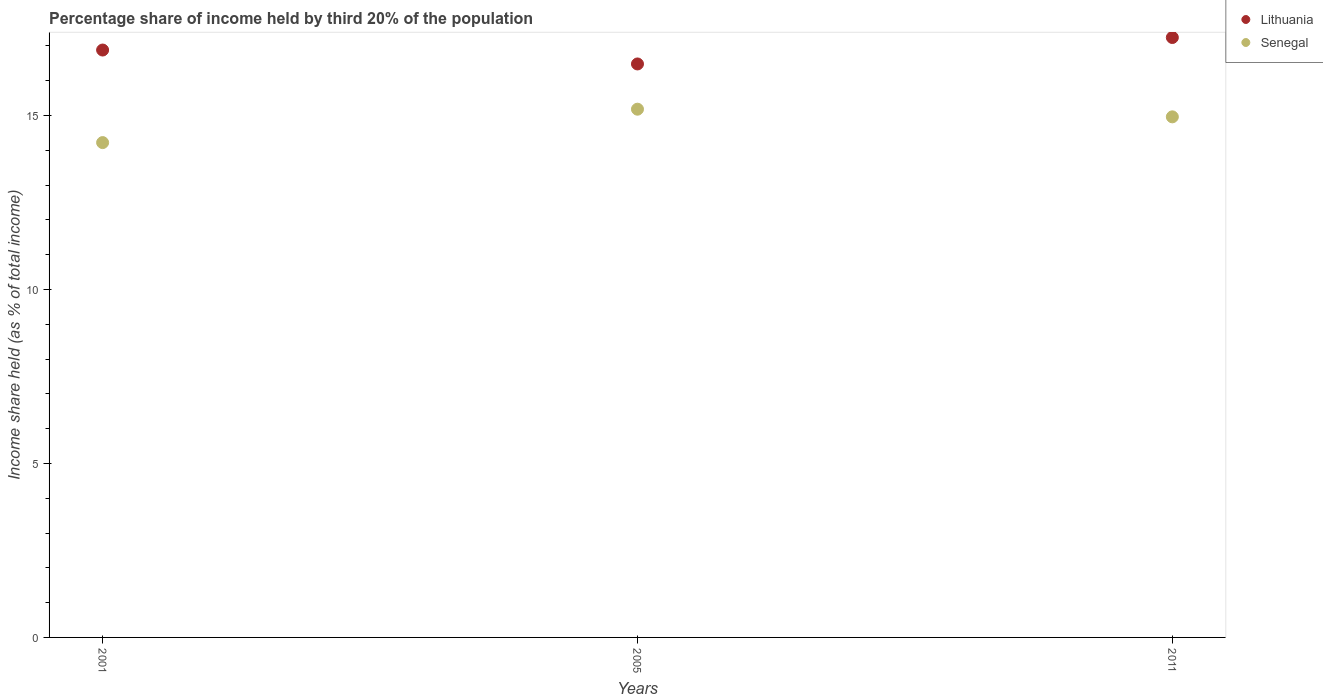What is the share of income held by third 20% of the population in Lithuania in 2005?
Ensure brevity in your answer.  16.48. Across all years, what is the maximum share of income held by third 20% of the population in Senegal?
Your response must be concise. 15.18. Across all years, what is the minimum share of income held by third 20% of the population in Senegal?
Keep it short and to the point. 14.22. In which year was the share of income held by third 20% of the population in Lithuania maximum?
Offer a terse response. 2011. What is the total share of income held by third 20% of the population in Senegal in the graph?
Offer a terse response. 44.36. What is the difference between the share of income held by third 20% of the population in Lithuania in 2001 and that in 2011?
Ensure brevity in your answer.  -0.36. What is the difference between the share of income held by third 20% of the population in Senegal in 2011 and the share of income held by third 20% of the population in Lithuania in 2005?
Provide a succinct answer. -1.52. What is the average share of income held by third 20% of the population in Senegal per year?
Keep it short and to the point. 14.79. In the year 2005, what is the difference between the share of income held by third 20% of the population in Lithuania and share of income held by third 20% of the population in Senegal?
Your answer should be very brief. 1.3. In how many years, is the share of income held by third 20% of the population in Lithuania greater than 6 %?
Offer a very short reply. 3. What is the ratio of the share of income held by third 20% of the population in Senegal in 2001 to that in 2011?
Provide a succinct answer. 0.95. Is the share of income held by third 20% of the population in Lithuania in 2005 less than that in 2011?
Offer a very short reply. Yes. Is the difference between the share of income held by third 20% of the population in Lithuania in 2001 and 2011 greater than the difference between the share of income held by third 20% of the population in Senegal in 2001 and 2011?
Your answer should be very brief. Yes. What is the difference between the highest and the second highest share of income held by third 20% of the population in Senegal?
Ensure brevity in your answer.  0.22. What is the difference between the highest and the lowest share of income held by third 20% of the population in Lithuania?
Provide a short and direct response. 0.76. In how many years, is the share of income held by third 20% of the population in Lithuania greater than the average share of income held by third 20% of the population in Lithuania taken over all years?
Give a very brief answer. 2. Is the sum of the share of income held by third 20% of the population in Senegal in 2005 and 2011 greater than the maximum share of income held by third 20% of the population in Lithuania across all years?
Your response must be concise. Yes. Is the share of income held by third 20% of the population in Senegal strictly greater than the share of income held by third 20% of the population in Lithuania over the years?
Ensure brevity in your answer.  No. How many dotlines are there?
Offer a very short reply. 2. What is the difference between two consecutive major ticks on the Y-axis?
Your answer should be compact. 5. How many legend labels are there?
Provide a succinct answer. 2. What is the title of the graph?
Offer a very short reply. Percentage share of income held by third 20% of the population. What is the label or title of the Y-axis?
Your response must be concise. Income share held (as % of total income). What is the Income share held (as % of total income) of Lithuania in 2001?
Ensure brevity in your answer.  16.88. What is the Income share held (as % of total income) of Senegal in 2001?
Ensure brevity in your answer.  14.22. What is the Income share held (as % of total income) of Lithuania in 2005?
Give a very brief answer. 16.48. What is the Income share held (as % of total income) of Senegal in 2005?
Make the answer very short. 15.18. What is the Income share held (as % of total income) of Lithuania in 2011?
Keep it short and to the point. 17.24. What is the Income share held (as % of total income) of Senegal in 2011?
Your answer should be very brief. 14.96. Across all years, what is the maximum Income share held (as % of total income) of Lithuania?
Provide a succinct answer. 17.24. Across all years, what is the maximum Income share held (as % of total income) in Senegal?
Your answer should be compact. 15.18. Across all years, what is the minimum Income share held (as % of total income) of Lithuania?
Provide a succinct answer. 16.48. Across all years, what is the minimum Income share held (as % of total income) of Senegal?
Your response must be concise. 14.22. What is the total Income share held (as % of total income) in Lithuania in the graph?
Your answer should be compact. 50.6. What is the total Income share held (as % of total income) of Senegal in the graph?
Provide a succinct answer. 44.36. What is the difference between the Income share held (as % of total income) of Lithuania in 2001 and that in 2005?
Your response must be concise. 0.4. What is the difference between the Income share held (as % of total income) in Senegal in 2001 and that in 2005?
Make the answer very short. -0.96. What is the difference between the Income share held (as % of total income) in Lithuania in 2001 and that in 2011?
Give a very brief answer. -0.36. What is the difference between the Income share held (as % of total income) in Senegal in 2001 and that in 2011?
Provide a short and direct response. -0.74. What is the difference between the Income share held (as % of total income) of Lithuania in 2005 and that in 2011?
Provide a short and direct response. -0.76. What is the difference between the Income share held (as % of total income) in Senegal in 2005 and that in 2011?
Give a very brief answer. 0.22. What is the difference between the Income share held (as % of total income) in Lithuania in 2001 and the Income share held (as % of total income) in Senegal in 2011?
Provide a succinct answer. 1.92. What is the difference between the Income share held (as % of total income) of Lithuania in 2005 and the Income share held (as % of total income) of Senegal in 2011?
Provide a short and direct response. 1.52. What is the average Income share held (as % of total income) in Lithuania per year?
Offer a very short reply. 16.87. What is the average Income share held (as % of total income) in Senegal per year?
Offer a very short reply. 14.79. In the year 2001, what is the difference between the Income share held (as % of total income) of Lithuania and Income share held (as % of total income) of Senegal?
Your answer should be very brief. 2.66. In the year 2011, what is the difference between the Income share held (as % of total income) in Lithuania and Income share held (as % of total income) in Senegal?
Offer a very short reply. 2.28. What is the ratio of the Income share held (as % of total income) of Lithuania in 2001 to that in 2005?
Provide a short and direct response. 1.02. What is the ratio of the Income share held (as % of total income) of Senegal in 2001 to that in 2005?
Keep it short and to the point. 0.94. What is the ratio of the Income share held (as % of total income) in Lithuania in 2001 to that in 2011?
Your answer should be compact. 0.98. What is the ratio of the Income share held (as % of total income) in Senegal in 2001 to that in 2011?
Provide a succinct answer. 0.95. What is the ratio of the Income share held (as % of total income) in Lithuania in 2005 to that in 2011?
Your answer should be very brief. 0.96. What is the ratio of the Income share held (as % of total income) of Senegal in 2005 to that in 2011?
Your answer should be very brief. 1.01. What is the difference between the highest and the second highest Income share held (as % of total income) in Lithuania?
Offer a very short reply. 0.36. What is the difference between the highest and the second highest Income share held (as % of total income) of Senegal?
Your answer should be compact. 0.22. What is the difference between the highest and the lowest Income share held (as % of total income) in Lithuania?
Your answer should be very brief. 0.76. 